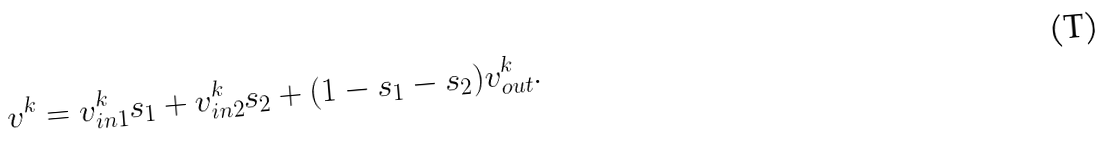<formula> <loc_0><loc_0><loc_500><loc_500>v ^ { k } = v ^ { k } _ { i n 1 } s _ { 1 } + v ^ { k } _ { i n 2 } s _ { 2 } + ( 1 - s _ { 1 } - s _ { 2 } ) v ^ { k } _ { o u t } .</formula> 